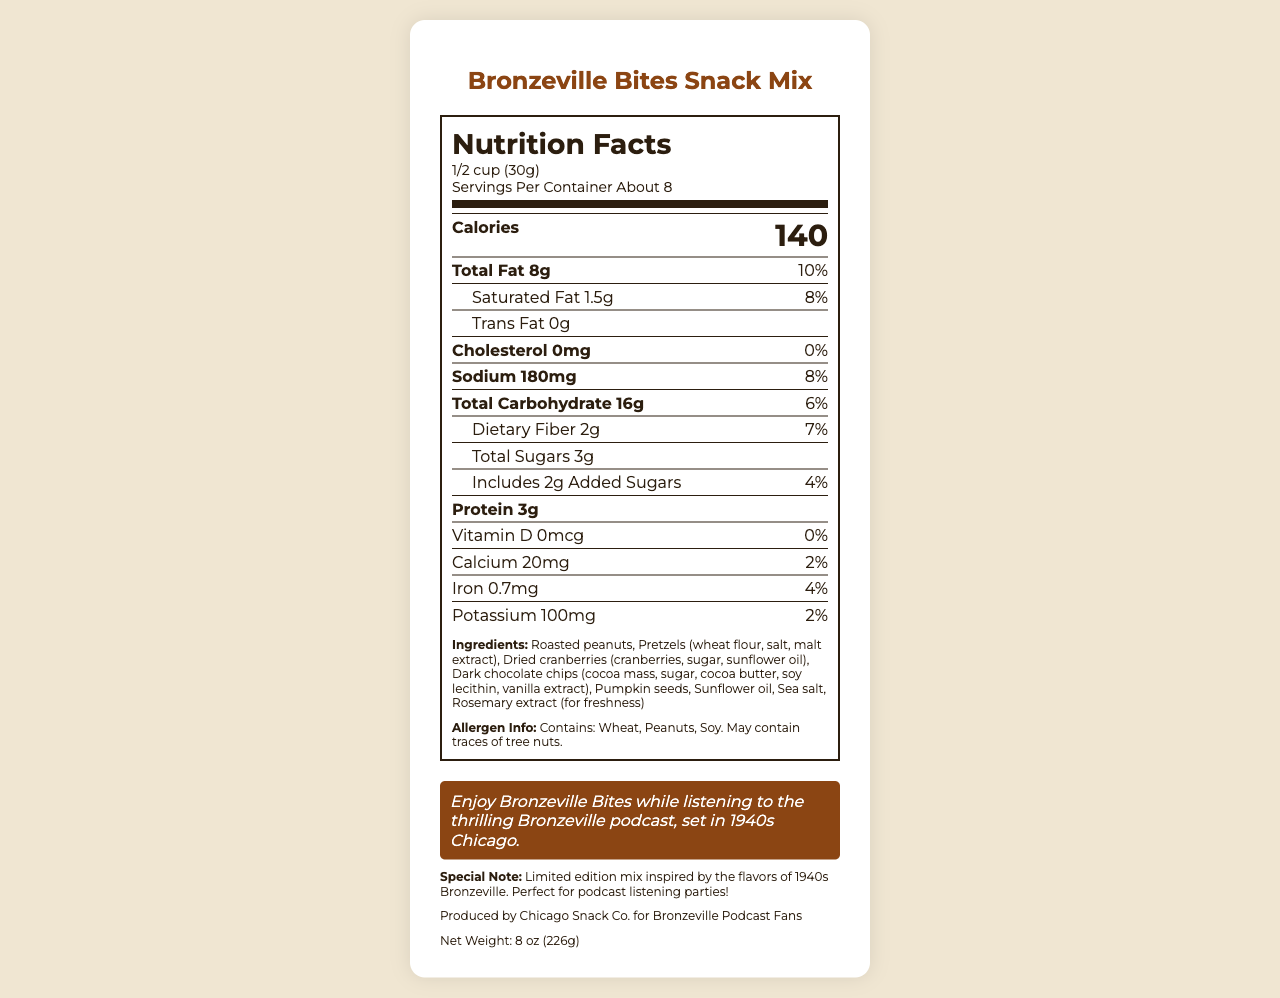What is the serving size of the Bronzeville Bites Snack Mix? The serving size is listed under the product name and nutrition title, showing "1/2 cup (30g)".
Answer: 1/2 cup (30g) How many calories are in one serving of Bronzeville Bites? The calories per serving are displayed prominently in the nutrition information as "Calories 140".
Answer: 140 What is the total fat content in one serving? The total fat content is indicated in the nutrition facts as "Total Fat 8g".
Answer: 8g How much iron is in one serving of the Bronzeville Bites Snack Mix? The amount of iron per serving is listed under the vitamins and minerals section with "Iron 0.7mg".
Answer: 0.7mg Does this snack contain any added sugars? If so, how much? The label shows "Includes 2g Added Sugars".
Answer: Yes, 2g Is the snack mix suitable for someone with a peanut allergy? The allergen info clearly states "Contains: Wheat, Peanuts, Soy".
Answer: No Which ingredient provides unsaturated fats in this snack mix? A. Roasted peanuts B. Pretzels C. Dark chocolate chips D. Sea salt Roasted peanuts are known to be a source of unsaturated fats.
Answer: A What is the net weight of the Bronzeville Bites Snack Mix? A. 6 oz (170g) B. 8 oz (226g) C. 10 oz (283g) The net weight is specified at the bottom of the document as "Net Weight: 8 oz (226g)".
Answer: B Are there any tree nuts in the Bronzeville Bites Snack Mix? The allergen info mentions "May contain traces of tree nuts".
Answer: Maybe Summarize the main information provided in the Bronzeville Bites Snack Mix nutrition document. The document aims to inform consumers about the nutritional content and allergen warnings of the snack, and its connection to the Bronzeville podcast.
Answer: The document provides the nutrition facts for Bronzeville Bites Snack Mix, including serving size, calories, fat content, and other nutrients. It lists all ingredients, allergen information, and a special note about the podcast. It also includes the net weight and manufacturer info. How much potassium is found in two servings of the snack mix? The nutrition label lists potassium as 100mg per serving. Since there are 2 servings, the total potassium is 100mg * 2 = 200mg.
Answer: 200mg Is there any Vitamin D in the Bronzeville Bites Snack Mix? The nutrition facts clearly state Vitamin D as "0mcg".
Answer: No What is the flavor inspiration behind the Bronzeville Bites Snack Mix? The special note mentions that the mix is inspired by the flavors of 1940s Bronzeville.
Answer: 1940s Bronzeville How much saturated fat does the snack contain per serving? The document shows the amount of saturated fat per serving as "1.5g".
Answer: 1.5g What is the protein content in two servings of this snack mix? One serving contains 3g of protein, so two servings contain 3g * 2 = 6g.
Answer: 6g Does the document state when the Bronzeville podcast was set? The podcast info section mentions the podcast is set in "1940s Chicago".
Answer: Yes, 1940s Chicago Who is the manufacturer of the Bronzeville Bites Snack Mix? The manufacturer info states that it is "Produced by Chicago Snack Co. for Bronzeville Podcast Fans".
Answer: Chicago Snack Co. Can you determine if the Bronzeville Bites Snack Mix is gluten-free based on the document? The document does not explicitly state whether the snack is gluten-free, although it mentions wheat in the ingredients and allergen info.
Answer: No 